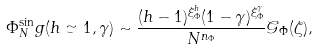<formula> <loc_0><loc_0><loc_500><loc_500>\Phi _ { N } ^ { \sin } g ( h \simeq 1 , \gamma ) \sim \frac { ( h - 1 ) ^ { \xi _ { \Phi } ^ { h } } ( 1 - \gamma ) ^ { \xi _ { \Phi } ^ { \gamma } } } { N ^ { n _ { \Phi } } } \mathcal { G } _ { \Phi } ( \zeta ) ,</formula> 